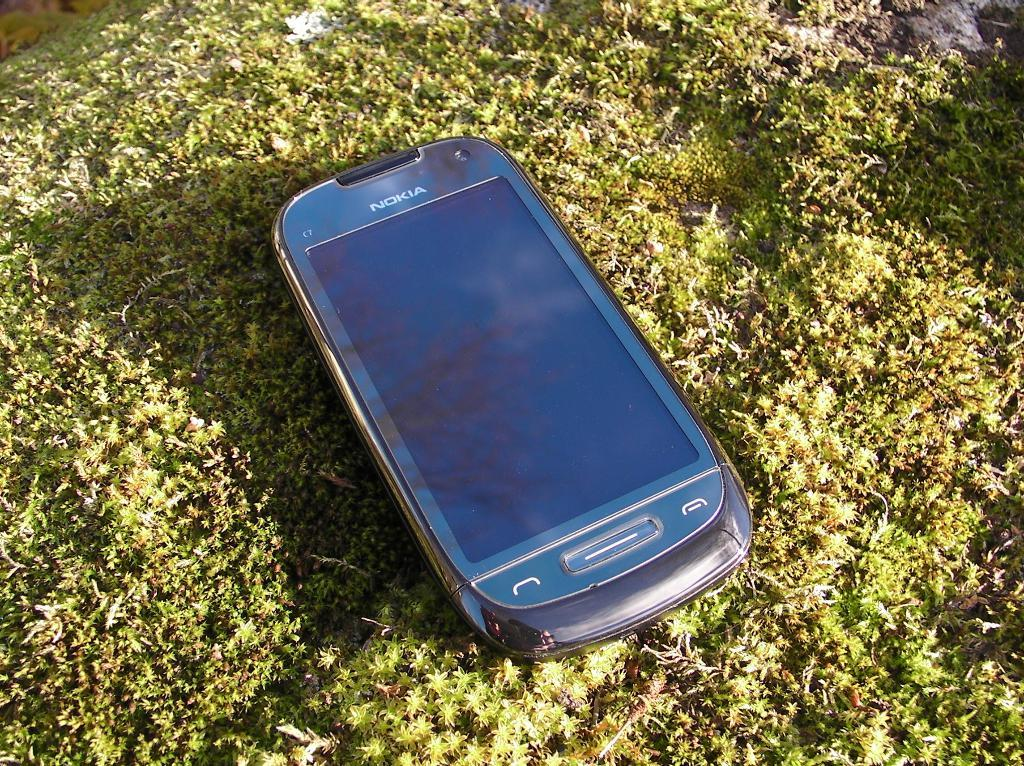<image>
Describe the image concisely. A Nokia cell phone lays on grass on a sunny day. 